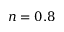Convert formula to latex. <formula><loc_0><loc_0><loc_500><loc_500>n = 0 . 8</formula> 